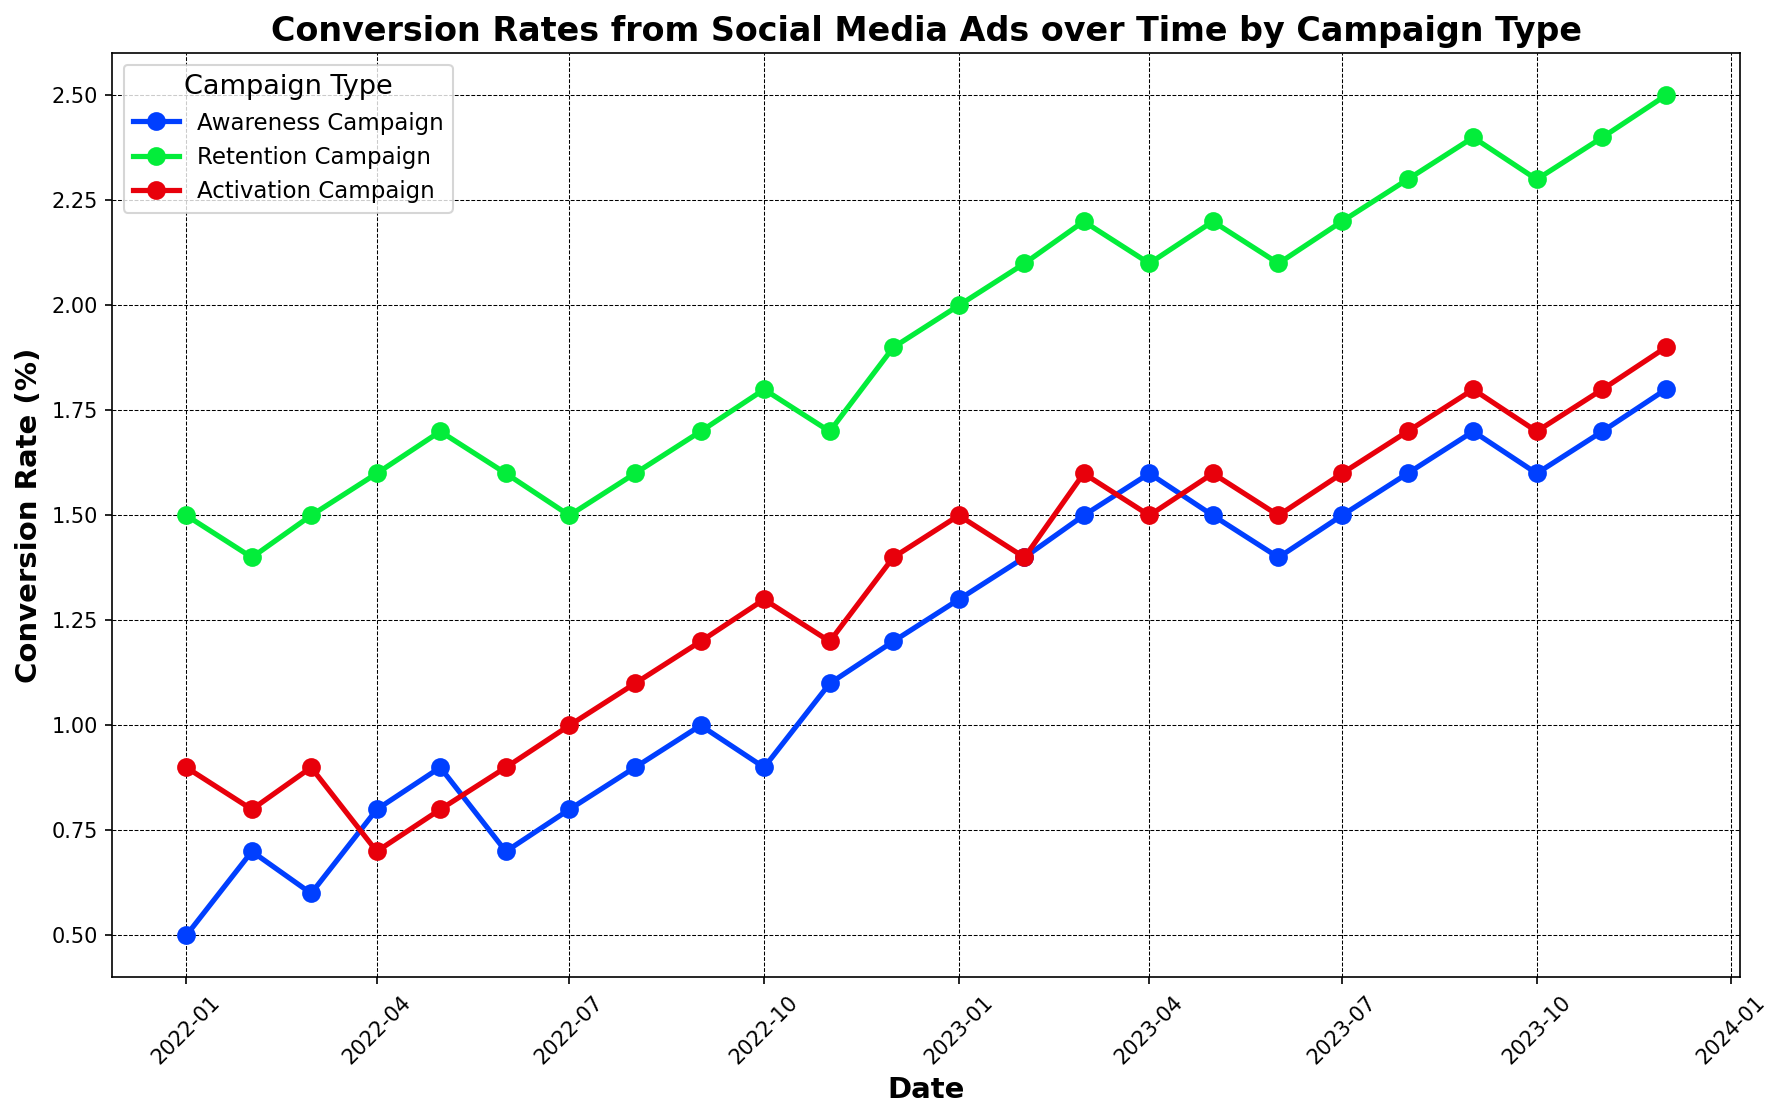what's the range of the conversion rates for the Awareness Campaign in 2023? The conversion rates for the Awareness Campaign in 2023 range from a minimum of 1.3% in January to a maximum of 1.8% in December. Therefore, the range is 1.8% - 1.3% = 0.5%
Answer: 0.5% which campaign type had the highest conversion rate at any point and when? The Retention Campaign had the highest conversion rate at 2.5% in December 2023. By examining all the conversion rates, it is evident that 2.5% was the peak value reached by any campaign type during the entire period.
Answer: Retention Campaign, December 2023 how did the conversion rate for the Activation Campaign change from January 2022 to January 2023? In January 2022, the conversion rate for the Activation Campaign was 0.9%, and in January 2023, it was 1.5%. The change in conversion rate is 1.5% - 0.9% = 0.6%. Therefore, the conversion rate increased by 0.6% over the year.
Answer: Increased by 0.6% between which two consecutive months did the Awareness Campaign show the most significant increase in conversion rate in 2022? For the Awareness Campaign in 2022, the most significant increase in conversion rate was observed between December (1.2%) and January (0.5%) of the same year. The increase is 1.2% - 0.5% = 0.7%.
Answer: January to February comparing October 2022 and October 2023, how did the conversion rate for the Retention Campaign change? The conversion rate for the Retention Campaign was 1.8% in October 2022 and 2.3% in October 2023. The difference is 2.3% - 1.8% = 0.5%. Therefore, it increased by 0.5%.
Answer: Increased by 0.5% did any campaign type show a consistent month-over-month increase in conversion rates throughout 2023? No campaign type showed a consistent month-over-month increase throughout 2023. The Awareness Campaign, Retention Campaign, and Activation Campaign all had months where the conversion rate plateaued or decreased. For example, the Retention Campaign saw a decrease from April to June 2023.
Answer: No can you compare the average conversion rates for all three campaign types in 2022? To find the average conversion rates for 2022, sum up the monthly rates for each campaign and divide by 12:
Awareness Campaign: (0.5+0.7+0.6+0.8+0.9+0.7+0.8+0.9+1.0+0.9+1.1+1.2)/12 = 0.83%. 
Retention Campaign: (1.5+1.4+1.5+1.6+1.7+1.6+1.5+1.6+1.7+1.8+1.7+1.9)/12 = 1.65%. 
Activation Campaign: (0.9+0.8+0.9+0.7+0.8+0.9+1.0+1.1+1.2+1.3+1.2+1.4)/12 = 1.02%. 
Thus, the Retention Campaign had the highest average conversion rate followed by the Activation Campaign, and then the Awareness Campaign.
Answer: Retention Campaign: 1.65%, Activation Campaign: 1.02%, Awareness Campaign: 0.83% which month showed the highest collective conversion rate across all campaign types in 2022? To find the month with the highest collective conversion rate, sum the conversion rates for each month in 2022 across all campaigns. The highest total collective conversion rate occurred in November 2022: Awareness Campaign (1.1%) + Retention Campaign (1.7%) + Activation Campaign (1.2%) = 4.0%.
Answer: November how did the conversion rate trends differ between the Retention Campaign and Awareness Campaign from January 2022 to December 2023? The Retention Campaign had higher conversion rates throughout the period compared to the Awareness Campaign. While the Awareness Campaign showed gradual increases with occasional plateaus or minor dips, the Retention Campaign generally demonstrated higher averages and more consistent growth. Specifically, the Retention Campaign's conversion rate increased from 1.5% in December 2022 to 2.5% in December 2023, whereas the Awareness Campaign’s conversion rate increased from 1.2% to 1.8% in the same period.
Answer: Higher for Retention Campaign, gradual increases but higher peaks what visual differences are notable in the trends of the Activation Campaign compared to the other campaigns? Visually, the Activation Campaign shows a more gradual and smoother trend with periodic minor increases and stabilizations, especially after the midyear period each year. In contrast, the Retention Campaign has higher peaks, and the Awareness Campaign has more fluctuation but generally stays lower than the Retention Campaign.
Answer: Gradual and smoother trend with periodical stabilizations 